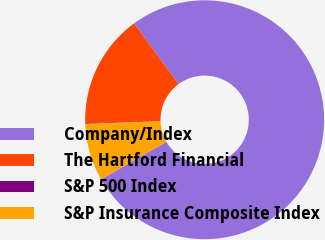<chart> <loc_0><loc_0><loc_500><loc_500><pie_chart><fcel>Company/Index<fcel>The Hartford Financial<fcel>S&P 500 Index<fcel>S&P Insurance Composite Index<nl><fcel>76.76%<fcel>15.42%<fcel>0.08%<fcel>7.75%<nl></chart> 